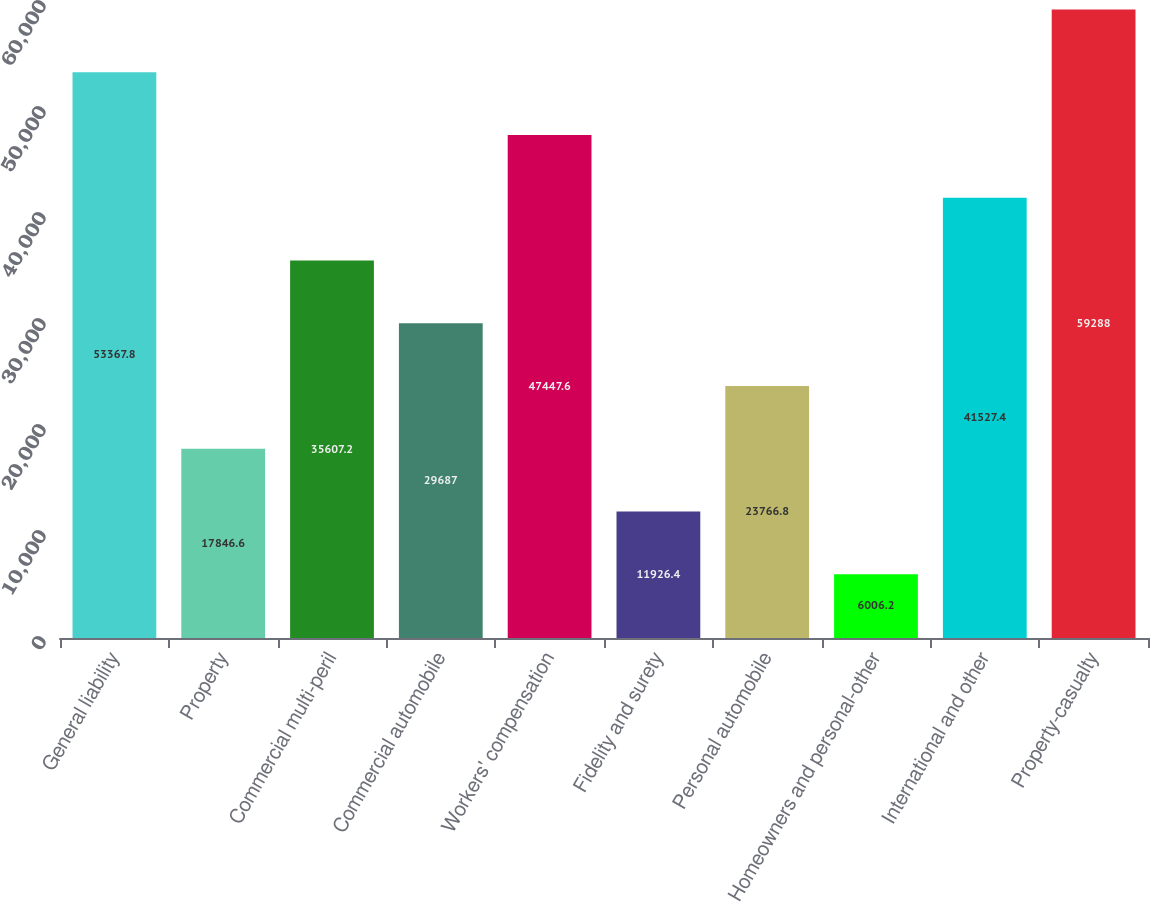Convert chart to OTSL. <chart><loc_0><loc_0><loc_500><loc_500><bar_chart><fcel>General liability<fcel>Property<fcel>Commercial multi-peril<fcel>Commercial automobile<fcel>Workers' compensation<fcel>Fidelity and surety<fcel>Personal automobile<fcel>Homeowners and personal-other<fcel>International and other<fcel>Property-casualty<nl><fcel>53367.8<fcel>17846.6<fcel>35607.2<fcel>29687<fcel>47447.6<fcel>11926.4<fcel>23766.8<fcel>6006.2<fcel>41527.4<fcel>59288<nl></chart> 